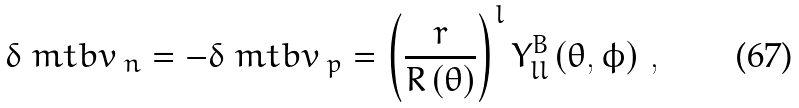<formula> <loc_0><loc_0><loc_500><loc_500>\delta \ m t b { v } _ { \ n } = - \delta \ m t b { v } _ { \ p } = \left ( \frac { r } { R \left ( \theta \right ) } \right ) ^ { l } Y _ { l l } ^ { B } \left ( \theta , \phi \right ) \, ,</formula> 